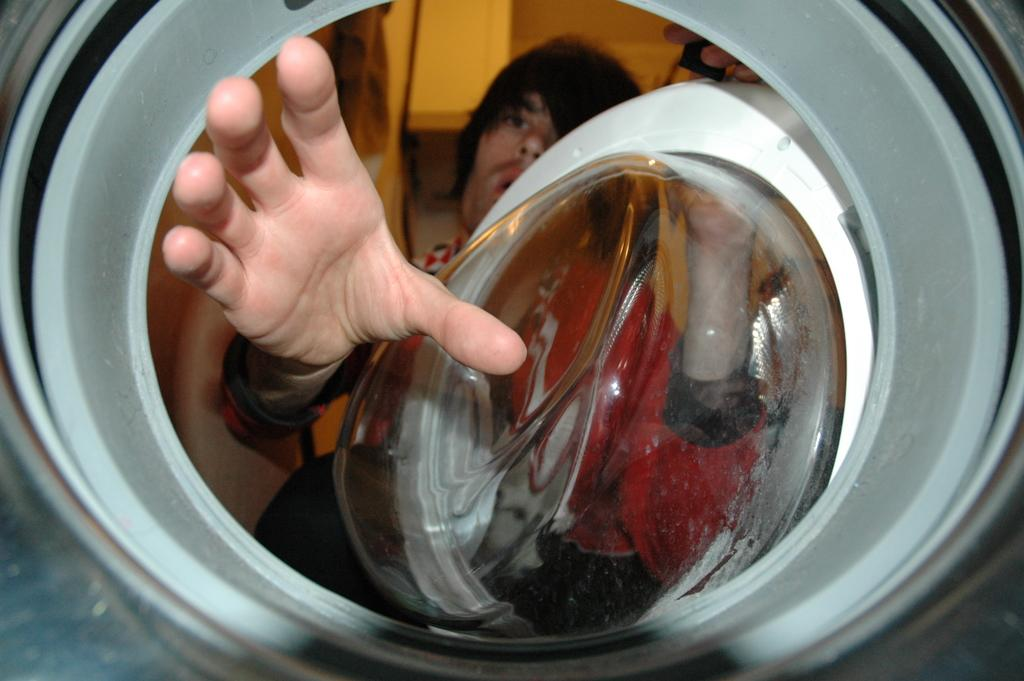What is the color of the object in the image? The object in the image is white. Can you describe the person in the image? There is a person in the middle of the image. What type of coat is the fairy wearing in the image? There are no fairies present in the image, and therefore no coat can be observed. 